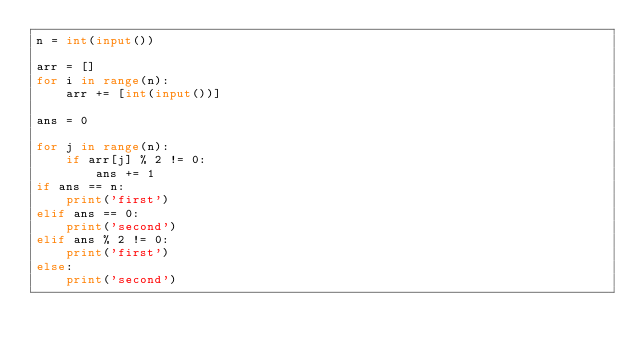Convert code to text. <code><loc_0><loc_0><loc_500><loc_500><_Python_>n = int(input())

arr = []
for i in range(n):
    arr += [int(input())]

ans = 0

for j in range(n):
    if arr[j] % 2 != 0:
        ans += 1
if ans == n:
    print('first')
elif ans == 0:
    print('second')
elif ans % 2 != 0:
    print('first')
else:
    print('second')
         </code> 